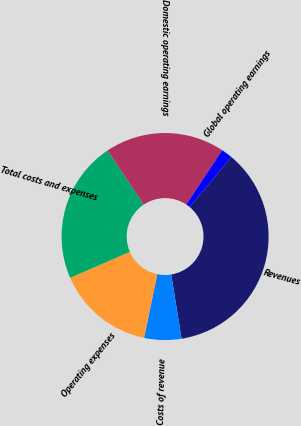Convert chart. <chart><loc_0><loc_0><loc_500><loc_500><pie_chart><fcel>Revenues<fcel>Costs of revenue<fcel>Operating expenses<fcel>Total costs and expenses<fcel>Domestic operating earnings<fcel>Global operating earnings<nl><fcel>36.41%<fcel>5.8%<fcel>15.22%<fcel>22.15%<fcel>18.68%<fcel>1.74%<nl></chart> 